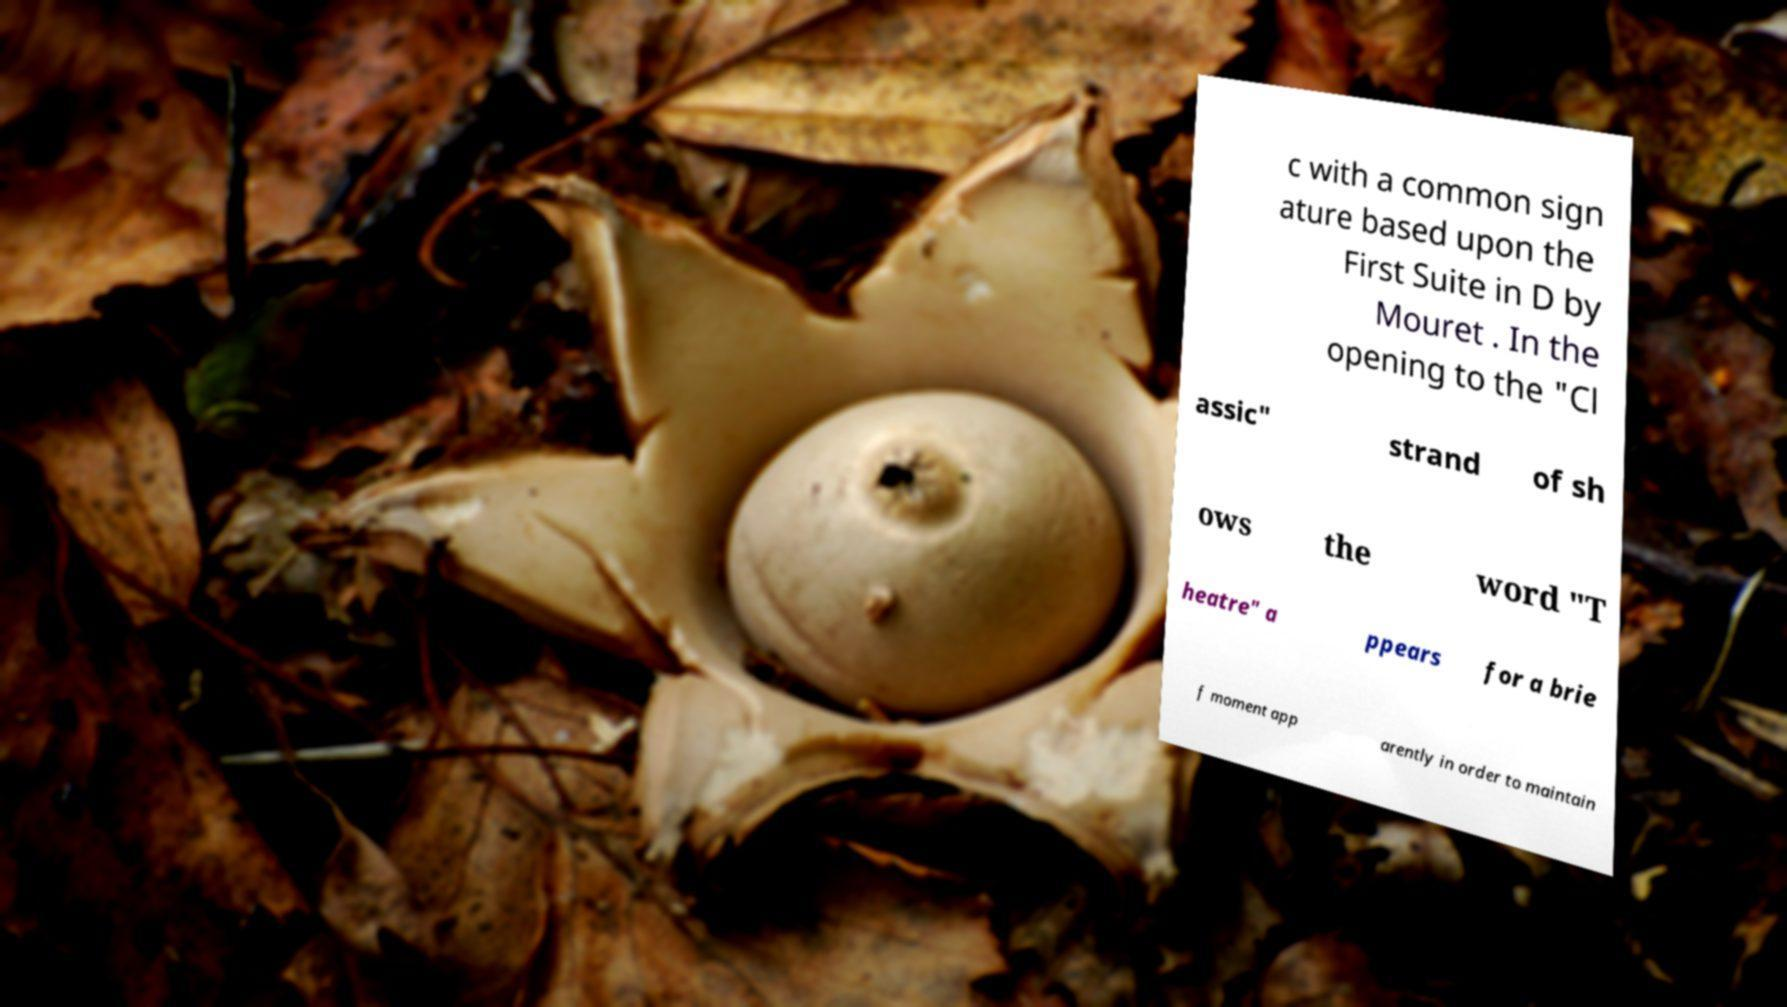There's text embedded in this image that I need extracted. Can you transcribe it verbatim? c with a common sign ature based upon the First Suite in D by Mouret . In the opening to the "Cl assic" strand of sh ows the word "T heatre" a ppears for a brie f moment app arently in order to maintain 